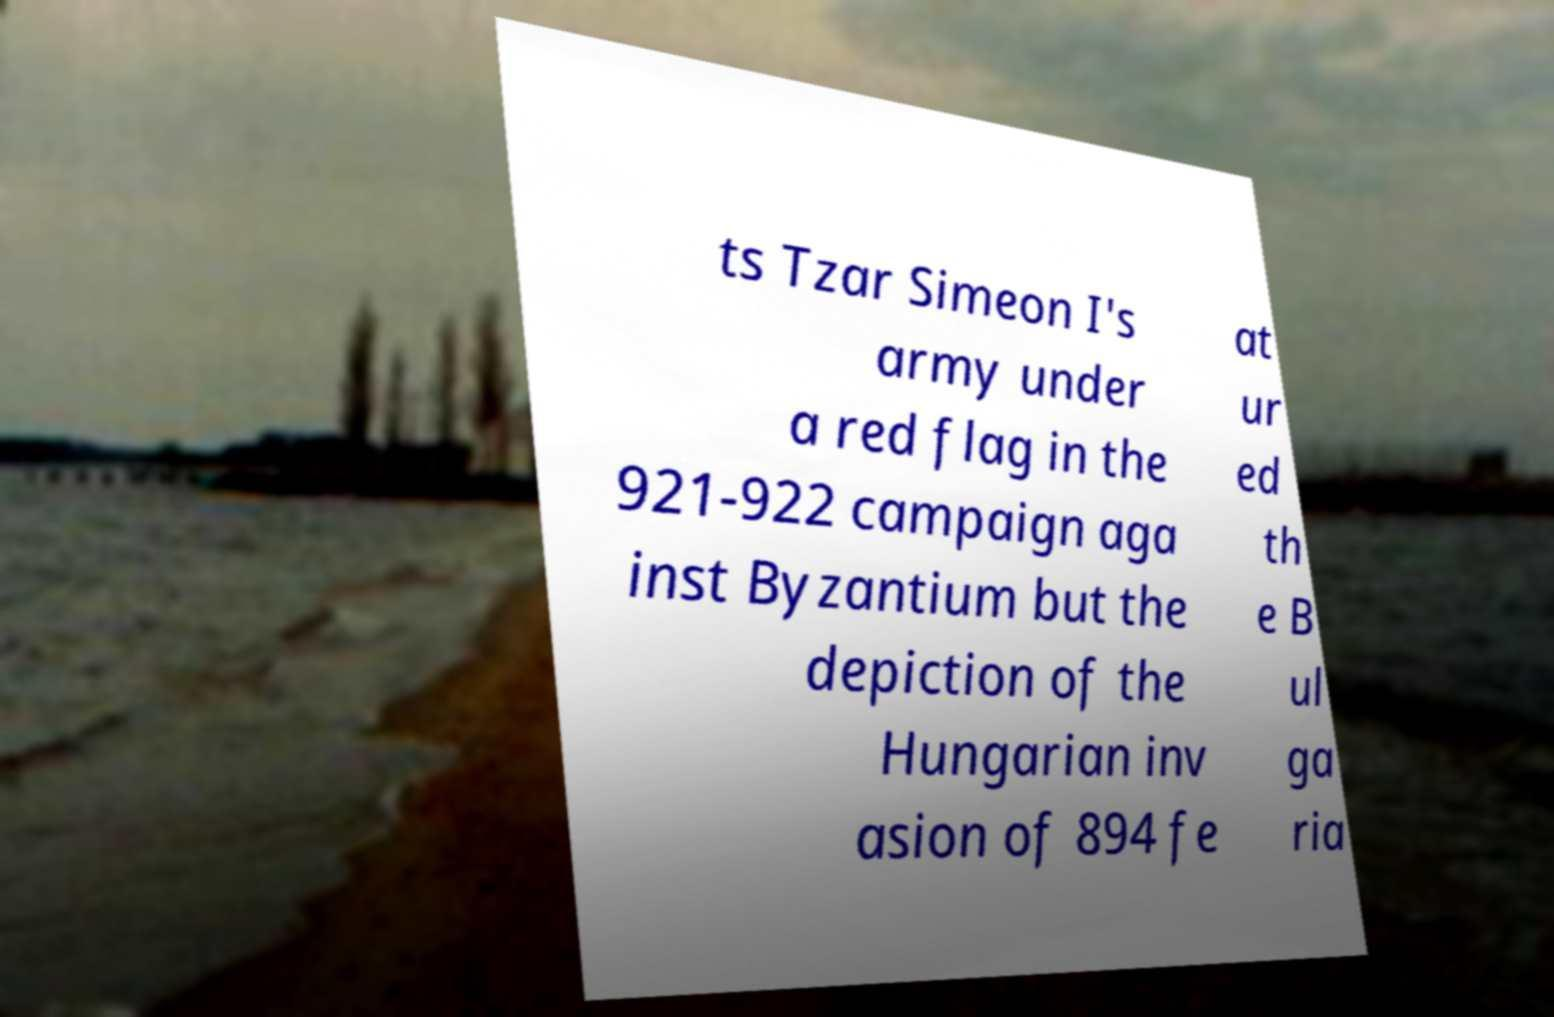For documentation purposes, I need the text within this image transcribed. Could you provide that? ts Tzar Simeon I's army under a red flag in the 921-922 campaign aga inst Byzantium but the depiction of the Hungarian inv asion of 894 fe at ur ed th e B ul ga ria 